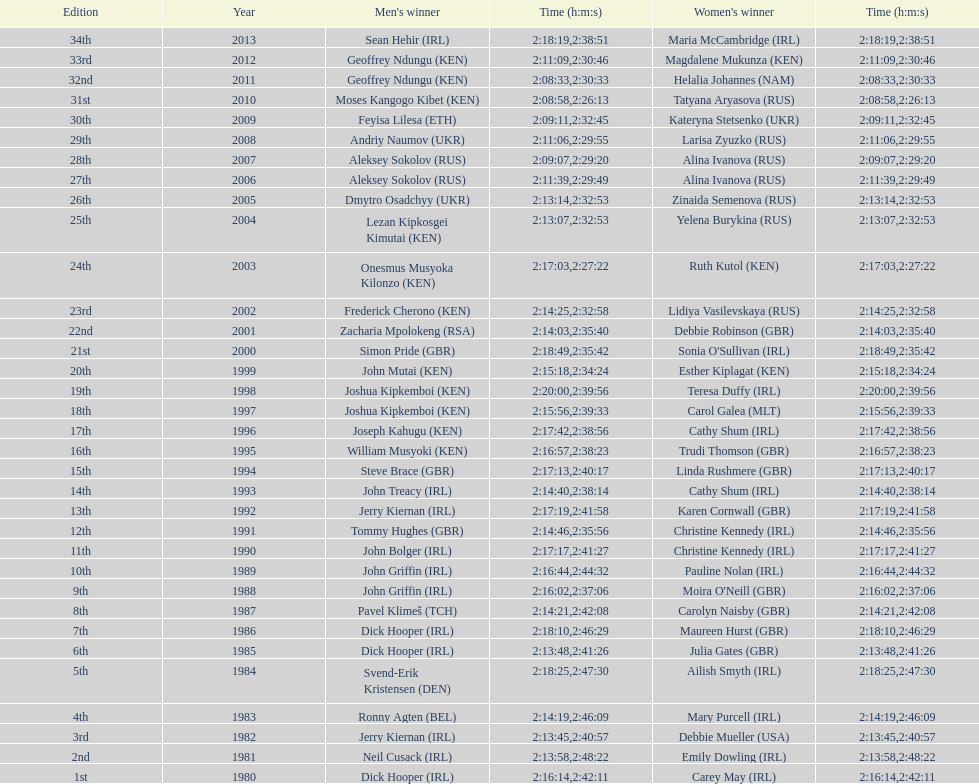Who possessed the most time out of all the participants? Maria McCambridge (IRL). 